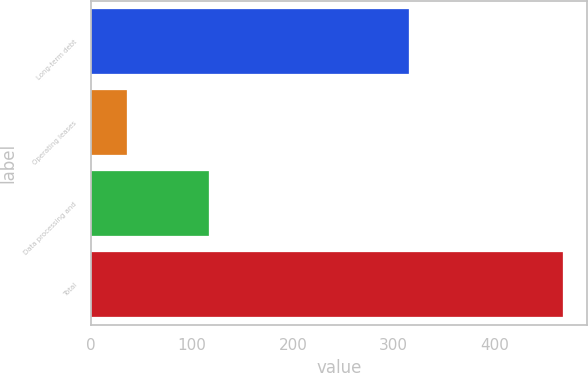Convert chart. <chart><loc_0><loc_0><loc_500><loc_500><bar_chart><fcel>Long-term debt<fcel>Operating leases<fcel>Data processing and<fcel>Total<nl><fcel>315.4<fcel>35.7<fcel>117<fcel>468.1<nl></chart> 